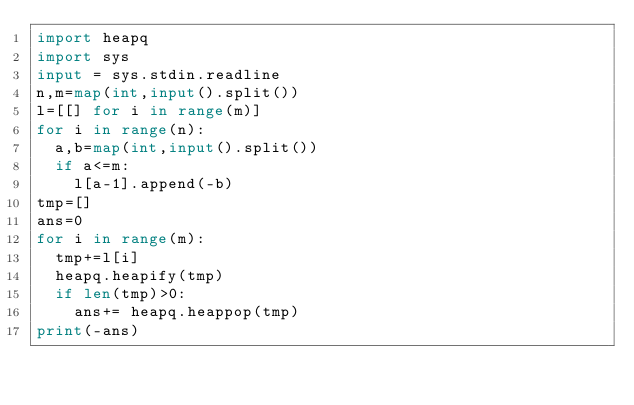Convert code to text. <code><loc_0><loc_0><loc_500><loc_500><_Python_>import heapq
import sys
input = sys.stdin.readline
n,m=map(int,input().split())
l=[[] for i in range(m)]
for i in range(n):
  a,b=map(int,input().split())
  if a<=m:
    l[a-1].append(-b)
tmp=[]
ans=0
for i in range(m):
  tmp+=l[i]
  heapq.heapify(tmp)
  if len(tmp)>0:
    ans+= heapq.heappop(tmp)
print(-ans)</code> 